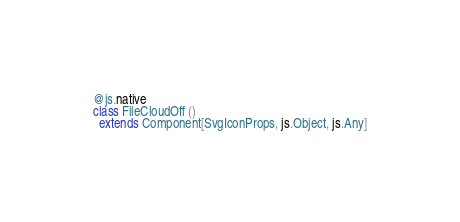<code> <loc_0><loc_0><loc_500><loc_500><_Scala_>@js.native
class FileCloudOff ()
  extends Component[SvgIconProps, js.Object, js.Any]
</code> 